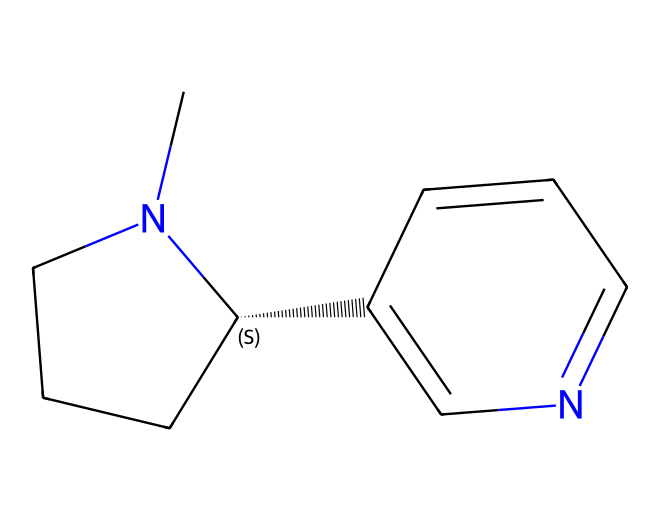What is the molecular formula of nicotine based on its structure? To determine the molecular formula, we need to count the number of each type of atom present in the SMILES representation. The structure indicates there are 10 carbon atoms (C), 14 hydrogen atoms (H), and 2 nitrogen atoms (N). Therefore, the molecular formula is C10H14N2.
Answer: C10H14N2 How many nitrogen atoms are in the nicotine structure? Looking at the chemical structure, the nitrogen atoms are represented in the SMILES with the letter "N". There are two occurrences of "N", indicating two nitrogen atoms in the structure.
Answer: 2 What type of cyclic structure is present in nicotine? The presence of a cycle in the chemical structure can be recognized from the "N1" and "C1" notations, which imply a ring formation. The structure contains a piperidine ring (six-membered), which is common in alkaloids.
Answer: piperidine Does nicotine contain any double bonds? By analyzing the SMILES representation, we can see from the "C2=CN" part that there is indeed a double bond between a carbon (C) and a nitrogen (N) atom, confirming the presence of a double bond in the structure.
Answer: yes What is the total number of rings present in the nicotine structure? In the structure, there are two separate cycles indicated by the "N1" and "C2" labels. Therefore, nicotine has a total of two rings.
Answer: 2 Is nicotine considered a basic or acidic substance? Nicotine has a basic nitrogen atom in its structure, making it capable of accepting protons. The presence of the nitrogen atoms gives it a basic characteristic typical of many alkaloids.
Answer: basic 